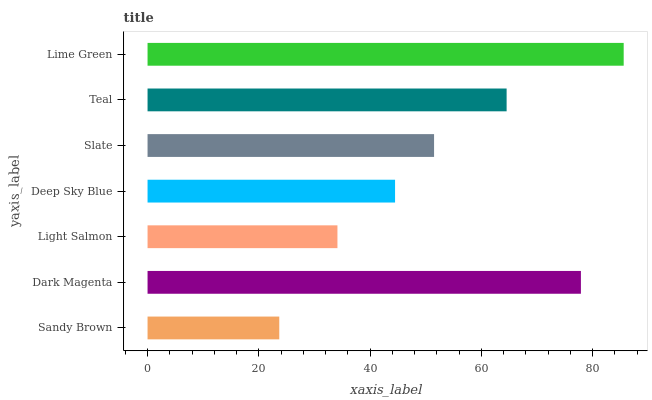Is Sandy Brown the minimum?
Answer yes or no. Yes. Is Lime Green the maximum?
Answer yes or no. Yes. Is Dark Magenta the minimum?
Answer yes or no. No. Is Dark Magenta the maximum?
Answer yes or no. No. Is Dark Magenta greater than Sandy Brown?
Answer yes or no. Yes. Is Sandy Brown less than Dark Magenta?
Answer yes or no. Yes. Is Sandy Brown greater than Dark Magenta?
Answer yes or no. No. Is Dark Magenta less than Sandy Brown?
Answer yes or no. No. Is Slate the high median?
Answer yes or no. Yes. Is Slate the low median?
Answer yes or no. Yes. Is Dark Magenta the high median?
Answer yes or no. No. Is Deep Sky Blue the low median?
Answer yes or no. No. 